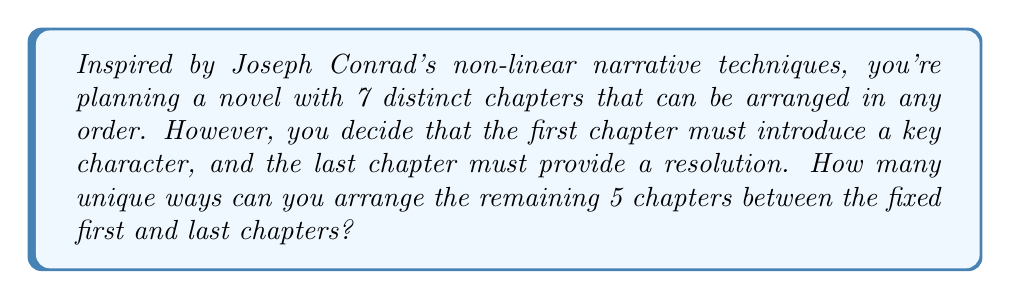Give your solution to this math problem. Let's approach this step-by-step:

1) We have 7 chapters in total, but the first and last chapters are fixed in position.

2) This means we need to focus on arranging the middle 5 chapters.

3) The number of ways to arrange 5 distinct items is given by the permutation formula:

   $$P(5,5) = 5!$$

4) Where 5! (5 factorial) is calculated as:

   $$5! = 5 \times 4 \times 3 \times 2 \times 1 = 120$$

5) Therefore, there are 120 unique ways to arrange the 5 middle chapters.

6) The first and last chapters remain in their fixed positions for all of these arrangements.

This problem illustrates how combinatorics can be applied to narrative structure, allowing for a mathematical exploration of storytelling techniques similar to those employed by Joseph Conrad.
Answer: 120 